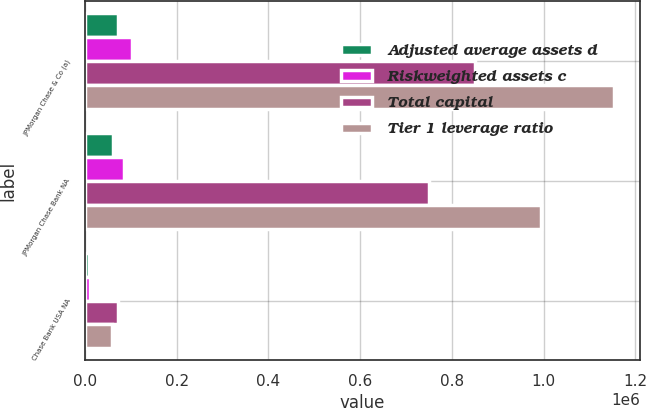Convert chart. <chart><loc_0><loc_0><loc_500><loc_500><stacked_bar_chart><ecel><fcel>JPMorgan Chase & Co (a)<fcel>JPMorgan Chase Bank NA<fcel>Chase Bank USA NA<nl><fcel>Adjusted average assets d<fcel>72474<fcel>61050<fcel>8608<nl><fcel>Riskweighted assets c<fcel>102437<fcel>84227<fcel>10941<nl><fcel>Total capital<fcel>850643<fcel>750397<fcel>72229<nl><fcel>Tier 1 leverage ratio<fcel>1.15255e+06<fcel>995095<fcel>59882<nl></chart> 